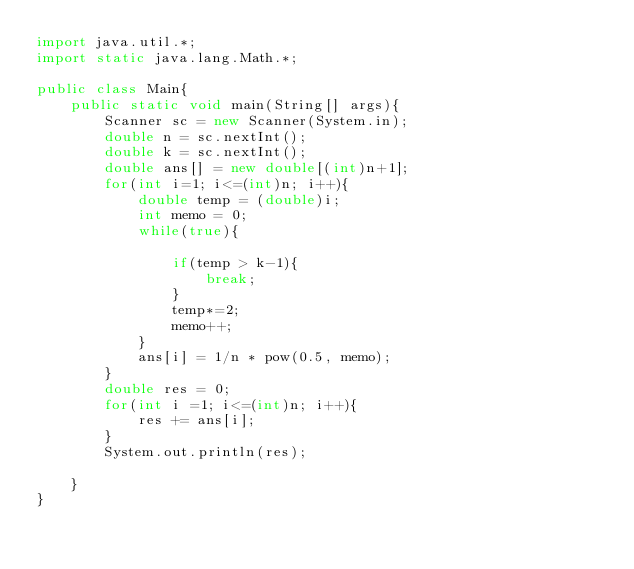<code> <loc_0><loc_0><loc_500><loc_500><_Java_>import java.util.*;
import static java.lang.Math.*;

public class Main{
    public static void main(String[] args){
        Scanner sc = new Scanner(System.in);
        double n = sc.nextInt();
        double k = sc.nextInt();
        double ans[] = new double[(int)n+1];
        for(int i=1; i<=(int)n; i++){
            double temp = (double)i;
            int memo = 0;
            while(true){
                
                if(temp > k-1){
                    break;
                }
                temp*=2;
                memo++;
            }
            ans[i] = 1/n * pow(0.5, memo);
        }
        double res = 0;
        for(int i =1; i<=(int)n; i++){
            res += ans[i]; 
        }
        System.out.println(res);

    }
}</code> 